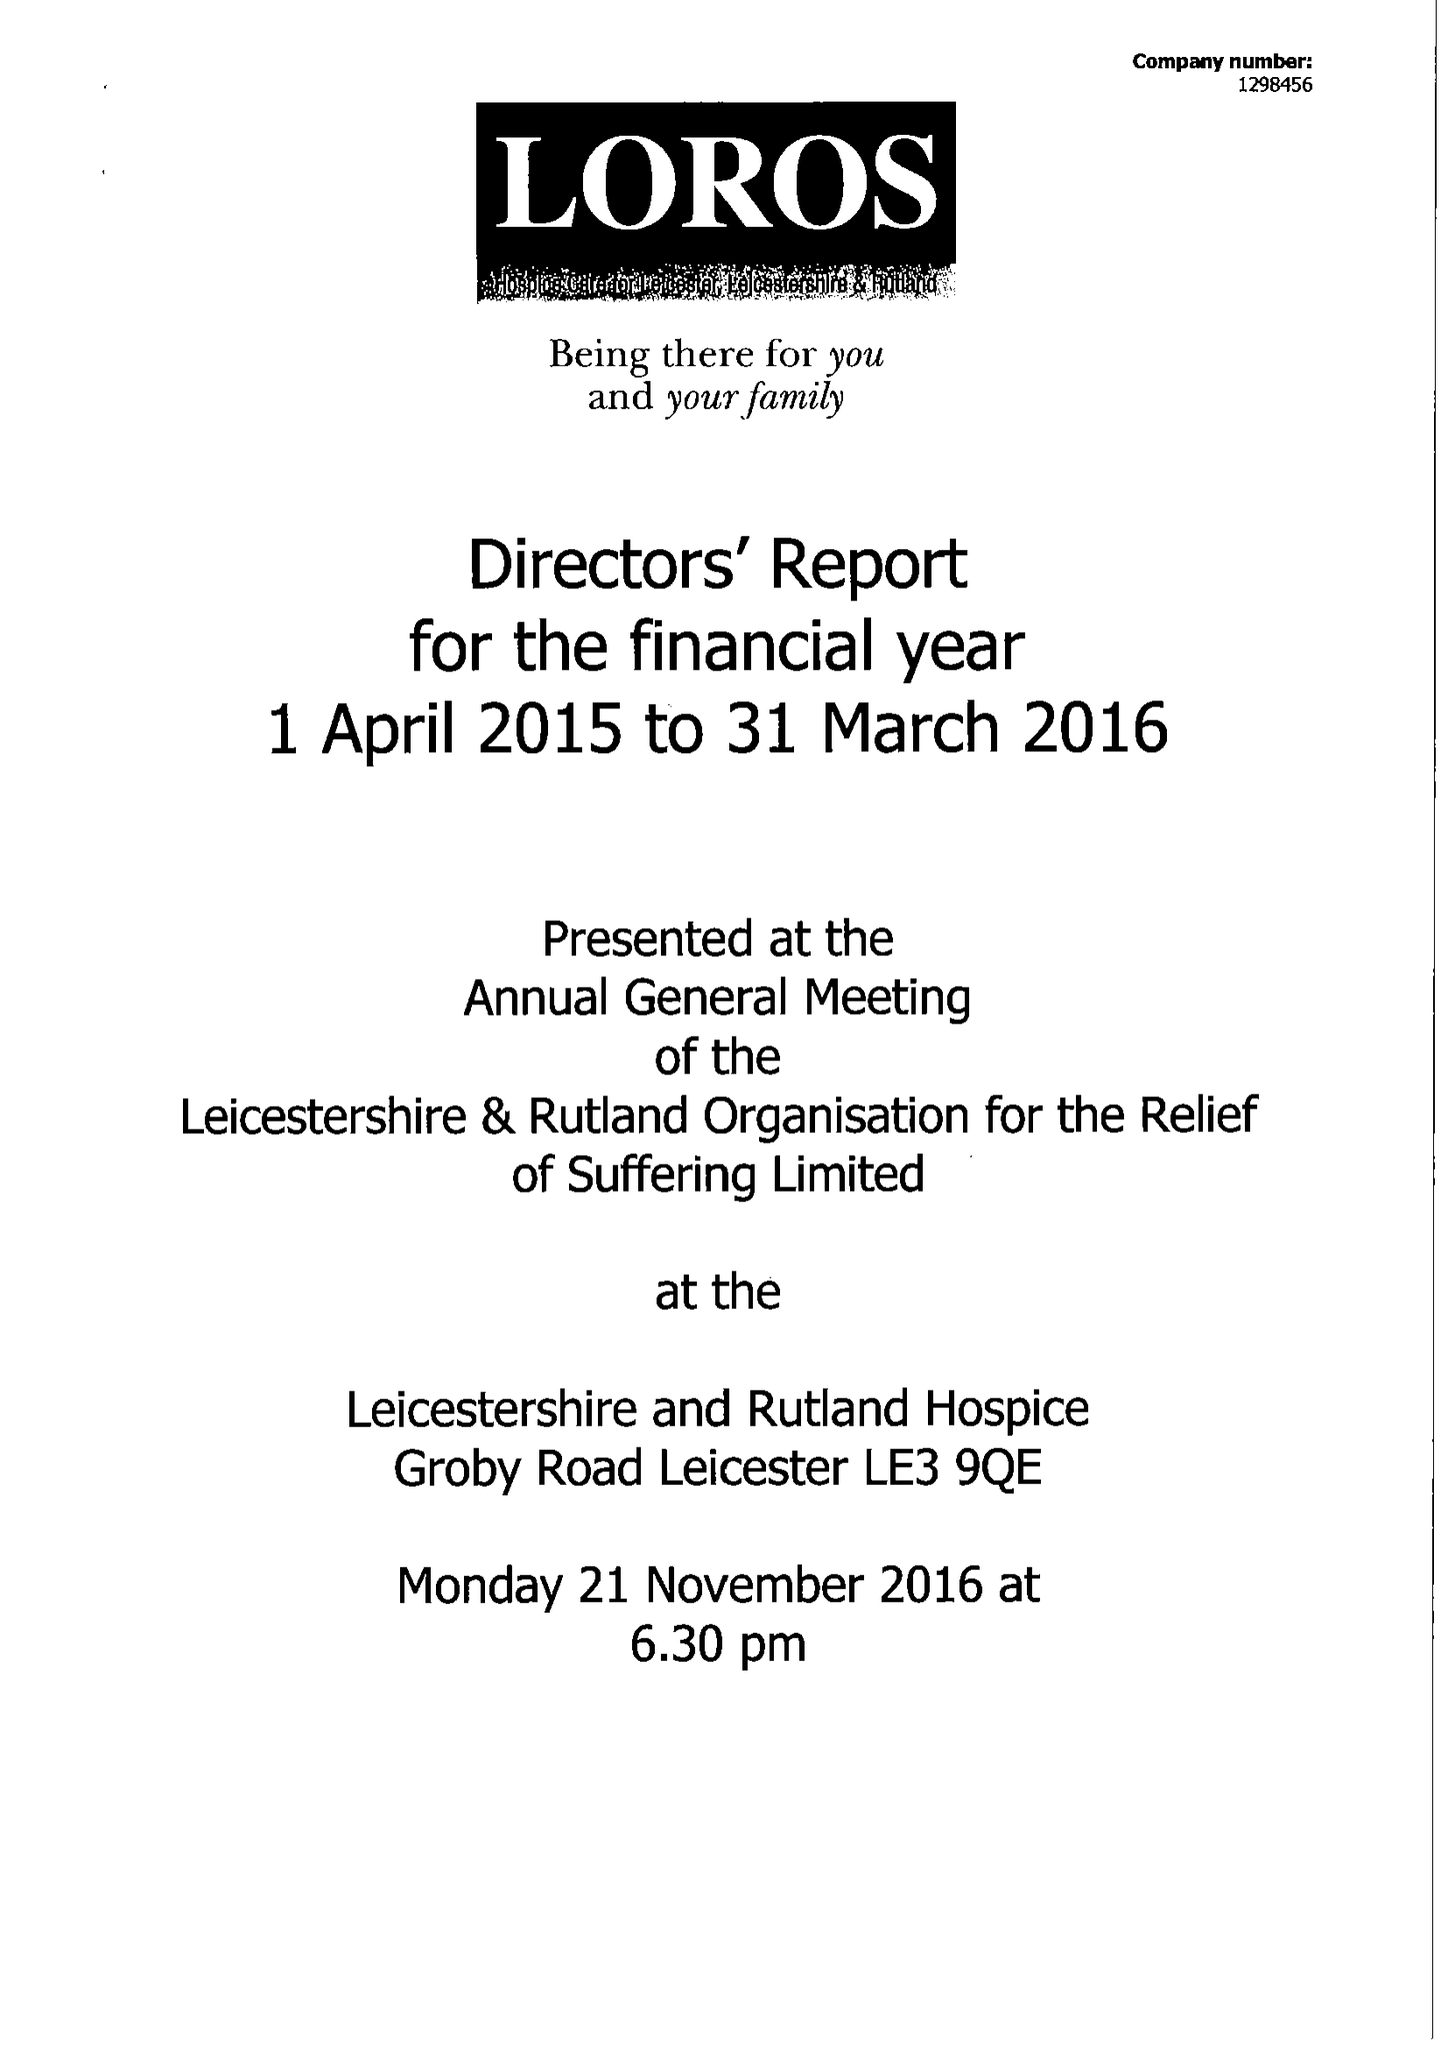What is the value for the spending_annually_in_british_pounds?
Answer the question using a single word or phrase. 11851790.00 